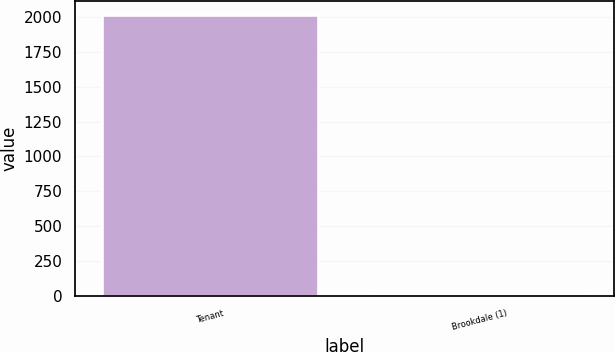Convert chart to OTSL. <chart><loc_0><loc_0><loc_500><loc_500><bar_chart><fcel>Tenant<fcel>Brookdale (1)<nl><fcel>2017<fcel>8<nl></chart> 